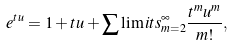Convert formula to latex. <formula><loc_0><loc_0><loc_500><loc_500>e ^ { t u } = 1 + t u + \sum \lim i t s _ { m = 2 } ^ { \infty } \frac { t ^ { m } u ^ { m } } { m ! } ,</formula> 